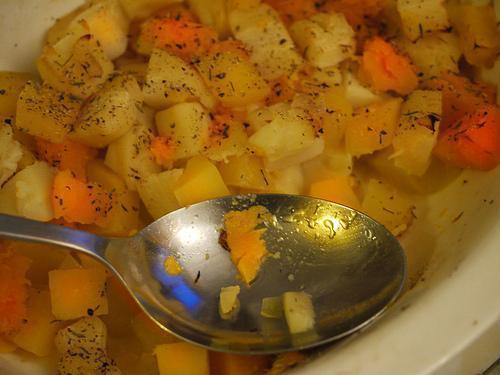How many spoons do you see?
Give a very brief answer. 1. 